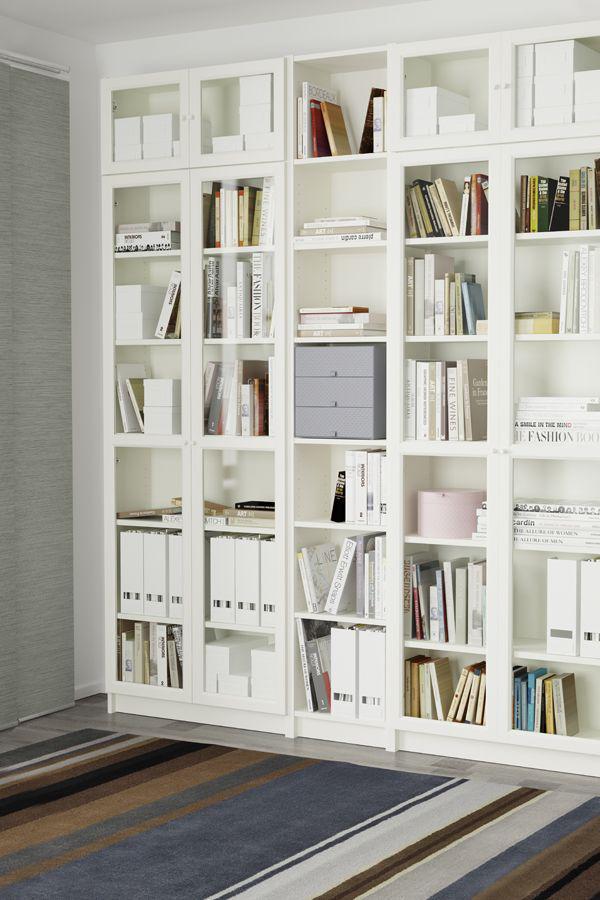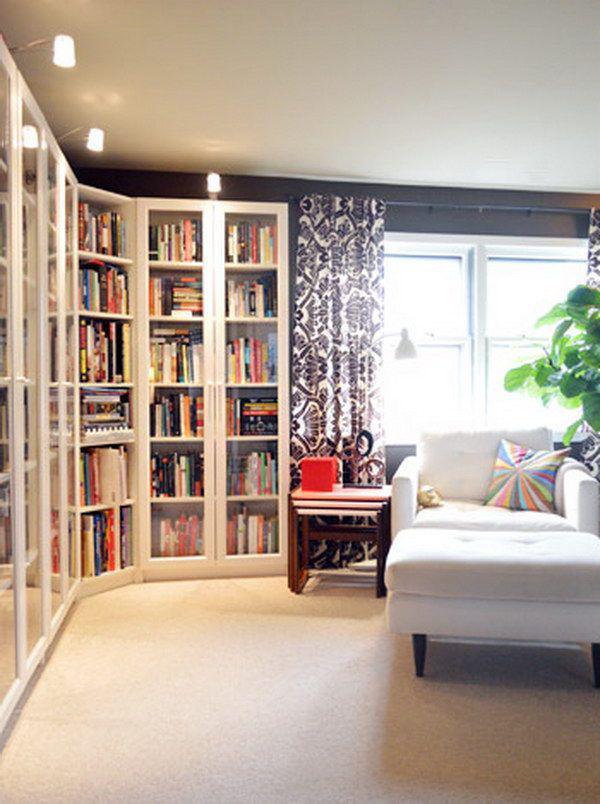The first image is the image on the left, the second image is the image on the right. Given the left and right images, does the statement "In one image, a floor to ceiling white shelving unit is curved around the corner of a room." hold true? Answer yes or no. Yes. 